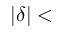Convert formula to latex. <formula><loc_0><loc_0><loc_500><loc_500>| \delta | <</formula> 